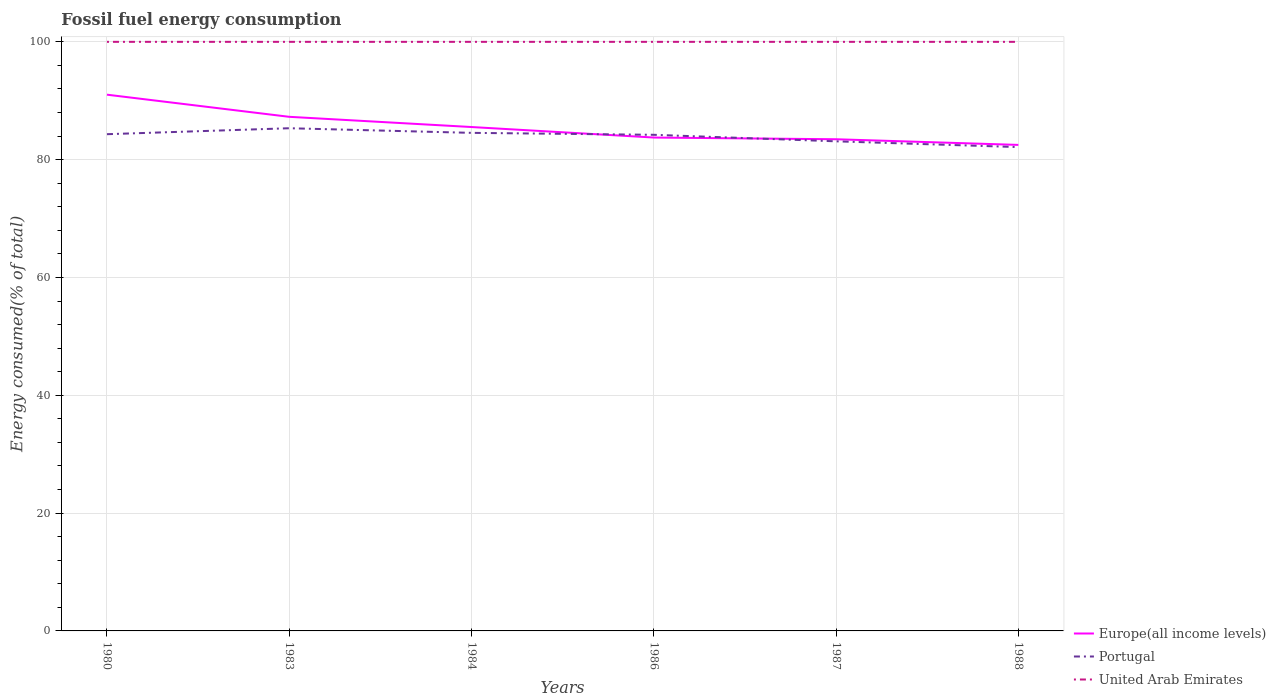Is the number of lines equal to the number of legend labels?
Offer a very short reply. Yes. Across all years, what is the maximum percentage of energy consumed in Portugal?
Make the answer very short. 82.13. What is the total percentage of energy consumed in Europe(all income levels) in the graph?
Provide a succinct answer. 1.73. What is the difference between the highest and the second highest percentage of energy consumed in Portugal?
Offer a very short reply. 3.2. What is the difference between the highest and the lowest percentage of energy consumed in United Arab Emirates?
Your response must be concise. 3. How many years are there in the graph?
Offer a terse response. 6. What is the title of the graph?
Your answer should be very brief. Fossil fuel energy consumption. Does "East Asia (developing only)" appear as one of the legend labels in the graph?
Give a very brief answer. No. What is the label or title of the Y-axis?
Ensure brevity in your answer.  Energy consumed(% of total). What is the Energy consumed(% of total) of Europe(all income levels) in 1980?
Keep it short and to the point. 91.03. What is the Energy consumed(% of total) of Portugal in 1980?
Your response must be concise. 84.32. What is the Energy consumed(% of total) in United Arab Emirates in 1980?
Your answer should be compact. 100. What is the Energy consumed(% of total) of Europe(all income levels) in 1983?
Offer a terse response. 87.27. What is the Energy consumed(% of total) of Portugal in 1983?
Ensure brevity in your answer.  85.33. What is the Energy consumed(% of total) of United Arab Emirates in 1983?
Make the answer very short. 100. What is the Energy consumed(% of total) of Europe(all income levels) in 1984?
Provide a short and direct response. 85.54. What is the Energy consumed(% of total) of Portugal in 1984?
Offer a very short reply. 84.55. What is the Energy consumed(% of total) of United Arab Emirates in 1984?
Make the answer very short. 100. What is the Energy consumed(% of total) of Europe(all income levels) in 1986?
Provide a succinct answer. 83.75. What is the Energy consumed(% of total) of Portugal in 1986?
Your answer should be compact. 84.22. What is the Energy consumed(% of total) in Europe(all income levels) in 1987?
Make the answer very short. 83.46. What is the Energy consumed(% of total) of Portugal in 1987?
Offer a terse response. 83.11. What is the Energy consumed(% of total) in Europe(all income levels) in 1988?
Your answer should be compact. 82.5. What is the Energy consumed(% of total) in Portugal in 1988?
Your answer should be compact. 82.13. Across all years, what is the maximum Energy consumed(% of total) in Europe(all income levels)?
Offer a very short reply. 91.03. Across all years, what is the maximum Energy consumed(% of total) of Portugal?
Give a very brief answer. 85.33. Across all years, what is the minimum Energy consumed(% of total) of Europe(all income levels)?
Make the answer very short. 82.5. Across all years, what is the minimum Energy consumed(% of total) in Portugal?
Your answer should be very brief. 82.13. Across all years, what is the minimum Energy consumed(% of total) in United Arab Emirates?
Provide a short and direct response. 100. What is the total Energy consumed(% of total) of Europe(all income levels) in the graph?
Provide a short and direct response. 513.56. What is the total Energy consumed(% of total) of Portugal in the graph?
Keep it short and to the point. 503.67. What is the total Energy consumed(% of total) in United Arab Emirates in the graph?
Ensure brevity in your answer.  600. What is the difference between the Energy consumed(% of total) in Europe(all income levels) in 1980 and that in 1983?
Offer a very short reply. 3.76. What is the difference between the Energy consumed(% of total) in Portugal in 1980 and that in 1983?
Your answer should be compact. -1.01. What is the difference between the Energy consumed(% of total) of United Arab Emirates in 1980 and that in 1983?
Offer a very short reply. -0. What is the difference between the Energy consumed(% of total) in Europe(all income levels) in 1980 and that in 1984?
Your response must be concise. 5.49. What is the difference between the Energy consumed(% of total) in Portugal in 1980 and that in 1984?
Provide a short and direct response. -0.23. What is the difference between the Energy consumed(% of total) of Europe(all income levels) in 1980 and that in 1986?
Offer a very short reply. 7.28. What is the difference between the Energy consumed(% of total) in Portugal in 1980 and that in 1986?
Ensure brevity in your answer.  0.1. What is the difference between the Energy consumed(% of total) of United Arab Emirates in 1980 and that in 1986?
Keep it short and to the point. -0. What is the difference between the Energy consumed(% of total) of Europe(all income levels) in 1980 and that in 1987?
Your response must be concise. 7.57. What is the difference between the Energy consumed(% of total) in Portugal in 1980 and that in 1987?
Make the answer very short. 1.21. What is the difference between the Energy consumed(% of total) of Europe(all income levels) in 1980 and that in 1988?
Your answer should be very brief. 8.53. What is the difference between the Energy consumed(% of total) in Portugal in 1980 and that in 1988?
Keep it short and to the point. 2.19. What is the difference between the Energy consumed(% of total) of Europe(all income levels) in 1983 and that in 1984?
Keep it short and to the point. 1.73. What is the difference between the Energy consumed(% of total) of Portugal in 1983 and that in 1984?
Provide a succinct answer. 0.78. What is the difference between the Energy consumed(% of total) of United Arab Emirates in 1983 and that in 1984?
Your answer should be very brief. -0. What is the difference between the Energy consumed(% of total) of Europe(all income levels) in 1983 and that in 1986?
Provide a succinct answer. 3.52. What is the difference between the Energy consumed(% of total) in Portugal in 1983 and that in 1986?
Provide a short and direct response. 1.12. What is the difference between the Energy consumed(% of total) of Europe(all income levels) in 1983 and that in 1987?
Your response must be concise. 3.81. What is the difference between the Energy consumed(% of total) of Portugal in 1983 and that in 1987?
Provide a short and direct response. 2.22. What is the difference between the Energy consumed(% of total) of United Arab Emirates in 1983 and that in 1987?
Make the answer very short. -0. What is the difference between the Energy consumed(% of total) of Europe(all income levels) in 1983 and that in 1988?
Offer a very short reply. 4.77. What is the difference between the Energy consumed(% of total) in Portugal in 1983 and that in 1988?
Provide a succinct answer. 3.2. What is the difference between the Energy consumed(% of total) in Europe(all income levels) in 1984 and that in 1986?
Your response must be concise. 1.78. What is the difference between the Energy consumed(% of total) in Portugal in 1984 and that in 1986?
Ensure brevity in your answer.  0.33. What is the difference between the Energy consumed(% of total) of Europe(all income levels) in 1984 and that in 1987?
Your answer should be compact. 2.07. What is the difference between the Energy consumed(% of total) in Portugal in 1984 and that in 1987?
Your response must be concise. 1.44. What is the difference between the Energy consumed(% of total) in Europe(all income levels) in 1984 and that in 1988?
Ensure brevity in your answer.  3.03. What is the difference between the Energy consumed(% of total) of Portugal in 1984 and that in 1988?
Offer a terse response. 2.42. What is the difference between the Energy consumed(% of total) of Europe(all income levels) in 1986 and that in 1987?
Ensure brevity in your answer.  0.29. What is the difference between the Energy consumed(% of total) of Portugal in 1986 and that in 1987?
Offer a very short reply. 1.11. What is the difference between the Energy consumed(% of total) of Europe(all income levels) in 1986 and that in 1988?
Provide a succinct answer. 1.25. What is the difference between the Energy consumed(% of total) in Portugal in 1986 and that in 1988?
Make the answer very short. 2.09. What is the difference between the Energy consumed(% of total) of Europe(all income levels) in 1987 and that in 1988?
Your answer should be very brief. 0.96. What is the difference between the Energy consumed(% of total) of Portugal in 1987 and that in 1988?
Your answer should be very brief. 0.98. What is the difference between the Energy consumed(% of total) of United Arab Emirates in 1987 and that in 1988?
Offer a very short reply. 0. What is the difference between the Energy consumed(% of total) of Europe(all income levels) in 1980 and the Energy consumed(% of total) of Portugal in 1983?
Provide a succinct answer. 5.7. What is the difference between the Energy consumed(% of total) in Europe(all income levels) in 1980 and the Energy consumed(% of total) in United Arab Emirates in 1983?
Ensure brevity in your answer.  -8.97. What is the difference between the Energy consumed(% of total) in Portugal in 1980 and the Energy consumed(% of total) in United Arab Emirates in 1983?
Ensure brevity in your answer.  -15.68. What is the difference between the Energy consumed(% of total) of Europe(all income levels) in 1980 and the Energy consumed(% of total) of Portugal in 1984?
Give a very brief answer. 6.48. What is the difference between the Energy consumed(% of total) of Europe(all income levels) in 1980 and the Energy consumed(% of total) of United Arab Emirates in 1984?
Keep it short and to the point. -8.97. What is the difference between the Energy consumed(% of total) in Portugal in 1980 and the Energy consumed(% of total) in United Arab Emirates in 1984?
Provide a short and direct response. -15.68. What is the difference between the Energy consumed(% of total) of Europe(all income levels) in 1980 and the Energy consumed(% of total) of Portugal in 1986?
Your answer should be compact. 6.81. What is the difference between the Energy consumed(% of total) in Europe(all income levels) in 1980 and the Energy consumed(% of total) in United Arab Emirates in 1986?
Ensure brevity in your answer.  -8.97. What is the difference between the Energy consumed(% of total) in Portugal in 1980 and the Energy consumed(% of total) in United Arab Emirates in 1986?
Your answer should be compact. -15.68. What is the difference between the Energy consumed(% of total) in Europe(all income levels) in 1980 and the Energy consumed(% of total) in Portugal in 1987?
Make the answer very short. 7.92. What is the difference between the Energy consumed(% of total) in Europe(all income levels) in 1980 and the Energy consumed(% of total) in United Arab Emirates in 1987?
Ensure brevity in your answer.  -8.97. What is the difference between the Energy consumed(% of total) in Portugal in 1980 and the Energy consumed(% of total) in United Arab Emirates in 1987?
Keep it short and to the point. -15.68. What is the difference between the Energy consumed(% of total) in Europe(all income levels) in 1980 and the Energy consumed(% of total) in Portugal in 1988?
Ensure brevity in your answer.  8.9. What is the difference between the Energy consumed(% of total) of Europe(all income levels) in 1980 and the Energy consumed(% of total) of United Arab Emirates in 1988?
Give a very brief answer. -8.97. What is the difference between the Energy consumed(% of total) in Portugal in 1980 and the Energy consumed(% of total) in United Arab Emirates in 1988?
Give a very brief answer. -15.68. What is the difference between the Energy consumed(% of total) in Europe(all income levels) in 1983 and the Energy consumed(% of total) in Portugal in 1984?
Provide a short and direct response. 2.72. What is the difference between the Energy consumed(% of total) in Europe(all income levels) in 1983 and the Energy consumed(% of total) in United Arab Emirates in 1984?
Make the answer very short. -12.73. What is the difference between the Energy consumed(% of total) of Portugal in 1983 and the Energy consumed(% of total) of United Arab Emirates in 1984?
Provide a short and direct response. -14.67. What is the difference between the Energy consumed(% of total) of Europe(all income levels) in 1983 and the Energy consumed(% of total) of Portugal in 1986?
Your answer should be compact. 3.05. What is the difference between the Energy consumed(% of total) of Europe(all income levels) in 1983 and the Energy consumed(% of total) of United Arab Emirates in 1986?
Ensure brevity in your answer.  -12.73. What is the difference between the Energy consumed(% of total) of Portugal in 1983 and the Energy consumed(% of total) of United Arab Emirates in 1986?
Provide a succinct answer. -14.67. What is the difference between the Energy consumed(% of total) in Europe(all income levels) in 1983 and the Energy consumed(% of total) in Portugal in 1987?
Provide a succinct answer. 4.16. What is the difference between the Energy consumed(% of total) in Europe(all income levels) in 1983 and the Energy consumed(% of total) in United Arab Emirates in 1987?
Give a very brief answer. -12.73. What is the difference between the Energy consumed(% of total) of Portugal in 1983 and the Energy consumed(% of total) of United Arab Emirates in 1987?
Your answer should be very brief. -14.67. What is the difference between the Energy consumed(% of total) of Europe(all income levels) in 1983 and the Energy consumed(% of total) of Portugal in 1988?
Your answer should be very brief. 5.14. What is the difference between the Energy consumed(% of total) in Europe(all income levels) in 1983 and the Energy consumed(% of total) in United Arab Emirates in 1988?
Provide a short and direct response. -12.73. What is the difference between the Energy consumed(% of total) of Portugal in 1983 and the Energy consumed(% of total) of United Arab Emirates in 1988?
Offer a very short reply. -14.67. What is the difference between the Energy consumed(% of total) of Europe(all income levels) in 1984 and the Energy consumed(% of total) of Portugal in 1986?
Offer a very short reply. 1.32. What is the difference between the Energy consumed(% of total) of Europe(all income levels) in 1984 and the Energy consumed(% of total) of United Arab Emirates in 1986?
Ensure brevity in your answer.  -14.46. What is the difference between the Energy consumed(% of total) in Portugal in 1984 and the Energy consumed(% of total) in United Arab Emirates in 1986?
Provide a succinct answer. -15.45. What is the difference between the Energy consumed(% of total) in Europe(all income levels) in 1984 and the Energy consumed(% of total) in Portugal in 1987?
Provide a succinct answer. 2.43. What is the difference between the Energy consumed(% of total) of Europe(all income levels) in 1984 and the Energy consumed(% of total) of United Arab Emirates in 1987?
Ensure brevity in your answer.  -14.46. What is the difference between the Energy consumed(% of total) of Portugal in 1984 and the Energy consumed(% of total) of United Arab Emirates in 1987?
Ensure brevity in your answer.  -15.45. What is the difference between the Energy consumed(% of total) of Europe(all income levels) in 1984 and the Energy consumed(% of total) of Portugal in 1988?
Provide a short and direct response. 3.41. What is the difference between the Energy consumed(% of total) in Europe(all income levels) in 1984 and the Energy consumed(% of total) in United Arab Emirates in 1988?
Your answer should be very brief. -14.46. What is the difference between the Energy consumed(% of total) in Portugal in 1984 and the Energy consumed(% of total) in United Arab Emirates in 1988?
Keep it short and to the point. -15.45. What is the difference between the Energy consumed(% of total) of Europe(all income levels) in 1986 and the Energy consumed(% of total) of Portugal in 1987?
Your answer should be very brief. 0.64. What is the difference between the Energy consumed(% of total) of Europe(all income levels) in 1986 and the Energy consumed(% of total) of United Arab Emirates in 1987?
Provide a succinct answer. -16.25. What is the difference between the Energy consumed(% of total) of Portugal in 1986 and the Energy consumed(% of total) of United Arab Emirates in 1987?
Offer a very short reply. -15.78. What is the difference between the Energy consumed(% of total) of Europe(all income levels) in 1986 and the Energy consumed(% of total) of Portugal in 1988?
Offer a terse response. 1.62. What is the difference between the Energy consumed(% of total) in Europe(all income levels) in 1986 and the Energy consumed(% of total) in United Arab Emirates in 1988?
Your answer should be very brief. -16.25. What is the difference between the Energy consumed(% of total) of Portugal in 1986 and the Energy consumed(% of total) of United Arab Emirates in 1988?
Make the answer very short. -15.78. What is the difference between the Energy consumed(% of total) of Europe(all income levels) in 1987 and the Energy consumed(% of total) of Portugal in 1988?
Your answer should be compact. 1.33. What is the difference between the Energy consumed(% of total) in Europe(all income levels) in 1987 and the Energy consumed(% of total) in United Arab Emirates in 1988?
Keep it short and to the point. -16.54. What is the difference between the Energy consumed(% of total) of Portugal in 1987 and the Energy consumed(% of total) of United Arab Emirates in 1988?
Keep it short and to the point. -16.89. What is the average Energy consumed(% of total) in Europe(all income levels) per year?
Give a very brief answer. 85.59. What is the average Energy consumed(% of total) of Portugal per year?
Keep it short and to the point. 83.94. In the year 1980, what is the difference between the Energy consumed(% of total) of Europe(all income levels) and Energy consumed(% of total) of Portugal?
Give a very brief answer. 6.71. In the year 1980, what is the difference between the Energy consumed(% of total) in Europe(all income levels) and Energy consumed(% of total) in United Arab Emirates?
Offer a terse response. -8.97. In the year 1980, what is the difference between the Energy consumed(% of total) of Portugal and Energy consumed(% of total) of United Arab Emirates?
Give a very brief answer. -15.68. In the year 1983, what is the difference between the Energy consumed(% of total) of Europe(all income levels) and Energy consumed(% of total) of Portugal?
Offer a very short reply. 1.94. In the year 1983, what is the difference between the Energy consumed(% of total) of Europe(all income levels) and Energy consumed(% of total) of United Arab Emirates?
Your answer should be very brief. -12.73. In the year 1983, what is the difference between the Energy consumed(% of total) in Portugal and Energy consumed(% of total) in United Arab Emirates?
Your response must be concise. -14.67. In the year 1984, what is the difference between the Energy consumed(% of total) of Europe(all income levels) and Energy consumed(% of total) of United Arab Emirates?
Keep it short and to the point. -14.46. In the year 1984, what is the difference between the Energy consumed(% of total) of Portugal and Energy consumed(% of total) of United Arab Emirates?
Your response must be concise. -15.45. In the year 1986, what is the difference between the Energy consumed(% of total) of Europe(all income levels) and Energy consumed(% of total) of Portugal?
Keep it short and to the point. -0.46. In the year 1986, what is the difference between the Energy consumed(% of total) of Europe(all income levels) and Energy consumed(% of total) of United Arab Emirates?
Keep it short and to the point. -16.25. In the year 1986, what is the difference between the Energy consumed(% of total) in Portugal and Energy consumed(% of total) in United Arab Emirates?
Provide a succinct answer. -15.78. In the year 1987, what is the difference between the Energy consumed(% of total) of Europe(all income levels) and Energy consumed(% of total) of Portugal?
Your answer should be very brief. 0.35. In the year 1987, what is the difference between the Energy consumed(% of total) of Europe(all income levels) and Energy consumed(% of total) of United Arab Emirates?
Give a very brief answer. -16.54. In the year 1987, what is the difference between the Energy consumed(% of total) of Portugal and Energy consumed(% of total) of United Arab Emirates?
Provide a succinct answer. -16.89. In the year 1988, what is the difference between the Energy consumed(% of total) in Europe(all income levels) and Energy consumed(% of total) in Portugal?
Give a very brief answer. 0.37. In the year 1988, what is the difference between the Energy consumed(% of total) of Europe(all income levels) and Energy consumed(% of total) of United Arab Emirates?
Your answer should be compact. -17.5. In the year 1988, what is the difference between the Energy consumed(% of total) in Portugal and Energy consumed(% of total) in United Arab Emirates?
Your response must be concise. -17.87. What is the ratio of the Energy consumed(% of total) in Europe(all income levels) in 1980 to that in 1983?
Your response must be concise. 1.04. What is the ratio of the Energy consumed(% of total) in Portugal in 1980 to that in 1983?
Provide a short and direct response. 0.99. What is the ratio of the Energy consumed(% of total) in United Arab Emirates in 1980 to that in 1983?
Make the answer very short. 1. What is the ratio of the Energy consumed(% of total) of Europe(all income levels) in 1980 to that in 1984?
Offer a very short reply. 1.06. What is the ratio of the Energy consumed(% of total) in Portugal in 1980 to that in 1984?
Your answer should be compact. 1. What is the ratio of the Energy consumed(% of total) of United Arab Emirates in 1980 to that in 1984?
Give a very brief answer. 1. What is the ratio of the Energy consumed(% of total) of Europe(all income levels) in 1980 to that in 1986?
Make the answer very short. 1.09. What is the ratio of the Energy consumed(% of total) of Portugal in 1980 to that in 1986?
Your answer should be very brief. 1. What is the ratio of the Energy consumed(% of total) of United Arab Emirates in 1980 to that in 1986?
Keep it short and to the point. 1. What is the ratio of the Energy consumed(% of total) of Europe(all income levels) in 1980 to that in 1987?
Provide a succinct answer. 1.09. What is the ratio of the Energy consumed(% of total) of Portugal in 1980 to that in 1987?
Your answer should be very brief. 1.01. What is the ratio of the Energy consumed(% of total) in United Arab Emirates in 1980 to that in 1987?
Make the answer very short. 1. What is the ratio of the Energy consumed(% of total) of Europe(all income levels) in 1980 to that in 1988?
Provide a short and direct response. 1.1. What is the ratio of the Energy consumed(% of total) in Portugal in 1980 to that in 1988?
Keep it short and to the point. 1.03. What is the ratio of the Energy consumed(% of total) of Europe(all income levels) in 1983 to that in 1984?
Provide a succinct answer. 1.02. What is the ratio of the Energy consumed(% of total) of Portugal in 1983 to that in 1984?
Keep it short and to the point. 1.01. What is the ratio of the Energy consumed(% of total) of United Arab Emirates in 1983 to that in 1984?
Ensure brevity in your answer.  1. What is the ratio of the Energy consumed(% of total) of Europe(all income levels) in 1983 to that in 1986?
Your response must be concise. 1.04. What is the ratio of the Energy consumed(% of total) in Portugal in 1983 to that in 1986?
Offer a terse response. 1.01. What is the ratio of the Energy consumed(% of total) in United Arab Emirates in 1983 to that in 1986?
Offer a terse response. 1. What is the ratio of the Energy consumed(% of total) in Europe(all income levels) in 1983 to that in 1987?
Provide a short and direct response. 1.05. What is the ratio of the Energy consumed(% of total) of Portugal in 1983 to that in 1987?
Give a very brief answer. 1.03. What is the ratio of the Energy consumed(% of total) of United Arab Emirates in 1983 to that in 1987?
Provide a succinct answer. 1. What is the ratio of the Energy consumed(% of total) in Europe(all income levels) in 1983 to that in 1988?
Keep it short and to the point. 1.06. What is the ratio of the Energy consumed(% of total) in Portugal in 1983 to that in 1988?
Your answer should be compact. 1.04. What is the ratio of the Energy consumed(% of total) in Europe(all income levels) in 1984 to that in 1986?
Ensure brevity in your answer.  1.02. What is the ratio of the Energy consumed(% of total) in Portugal in 1984 to that in 1986?
Your response must be concise. 1. What is the ratio of the Energy consumed(% of total) in United Arab Emirates in 1984 to that in 1986?
Ensure brevity in your answer.  1. What is the ratio of the Energy consumed(% of total) in Europe(all income levels) in 1984 to that in 1987?
Provide a succinct answer. 1.02. What is the ratio of the Energy consumed(% of total) in Portugal in 1984 to that in 1987?
Provide a short and direct response. 1.02. What is the ratio of the Energy consumed(% of total) of Europe(all income levels) in 1984 to that in 1988?
Your answer should be very brief. 1.04. What is the ratio of the Energy consumed(% of total) of Portugal in 1984 to that in 1988?
Keep it short and to the point. 1.03. What is the ratio of the Energy consumed(% of total) of United Arab Emirates in 1984 to that in 1988?
Give a very brief answer. 1. What is the ratio of the Energy consumed(% of total) in Portugal in 1986 to that in 1987?
Provide a succinct answer. 1.01. What is the ratio of the Energy consumed(% of total) of United Arab Emirates in 1986 to that in 1987?
Your answer should be very brief. 1. What is the ratio of the Energy consumed(% of total) of Europe(all income levels) in 1986 to that in 1988?
Your answer should be very brief. 1.02. What is the ratio of the Energy consumed(% of total) of Portugal in 1986 to that in 1988?
Keep it short and to the point. 1.03. What is the ratio of the Energy consumed(% of total) in United Arab Emirates in 1986 to that in 1988?
Give a very brief answer. 1. What is the ratio of the Energy consumed(% of total) in Europe(all income levels) in 1987 to that in 1988?
Keep it short and to the point. 1.01. What is the ratio of the Energy consumed(% of total) of Portugal in 1987 to that in 1988?
Make the answer very short. 1.01. What is the difference between the highest and the second highest Energy consumed(% of total) of Europe(all income levels)?
Give a very brief answer. 3.76. What is the difference between the highest and the second highest Energy consumed(% of total) in Portugal?
Your answer should be compact. 0.78. What is the difference between the highest and the lowest Energy consumed(% of total) in Europe(all income levels)?
Make the answer very short. 8.53. What is the difference between the highest and the lowest Energy consumed(% of total) of Portugal?
Provide a short and direct response. 3.2. 